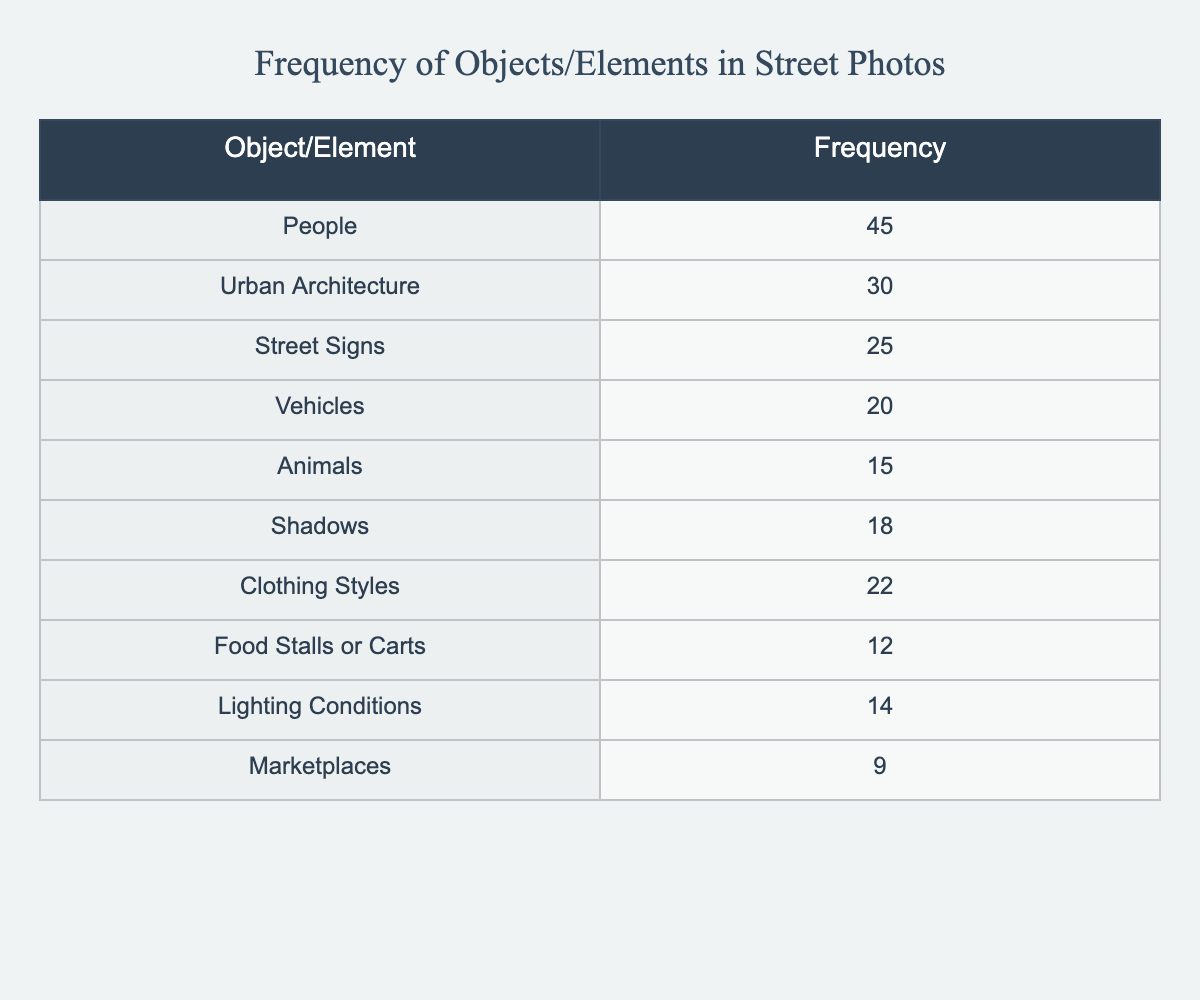What is the frequency of "Vehicles" in the table? The table lists "Vehicles" with a frequency of 20, which is directly stated in the data.
Answer: 20 Which object has a higher frequency: "People" or "Animals"? The frequency of "People" is 45, while "Animals" is 15. Since 45 > 15, "People" has a higher frequency.
Answer: People What is the total frequency of the objects or elements listed in the table? To find the total frequency, sum up all listed frequencies: 45 + 30 + 25 + 20 + 15 + 18 + 22 + 12 + 14 + 9 =  220.
Answer: 220 Is the frequency of "Lighting Conditions" greater than 10? The table shows that "Lighting Conditions" has a frequency of 14. Since 14 is greater than 10, this statement is true.
Answer: Yes What is the difference in frequency between "Urban Architecture" and "Street Signs"? "Urban Architecture" has a frequency of 30 and "Street Signs" has 25. The difference is calculated as 30 - 25 = 5.
Answer: 5 What is the average frequency of the items listed in the table? There are 10 items on the list. Total frequency is 220. The average is calculated by dividing the total by the number of items: 220 / 10 = 22.
Answer: 22 Which object category has the lowest frequency? By examining the table, "Marketplaces" has the lowest frequency with a value of 9, compared to all other objects' frequencies.
Answer: Marketplaces Is the frequency of "Clothing Styles" and "Food Stalls or Carts" combined greater than 40? The frequency of "Clothing Styles" is 22 and "Food Stalls or Carts" is 12. Their combined frequency is 22 + 12 = 34, which is not greater than 40.
Answer: No Which two objects combined have the frequency closest to 50? The items "Shadows" with 18 and "Lighting Conditions" with 14 sum up to 32, while "People" with 45 paired with "Street Signs" with 25 totals 70. The combination of "People" and "Street Signs" is closest to 50.
Answer: People and Street Signs 